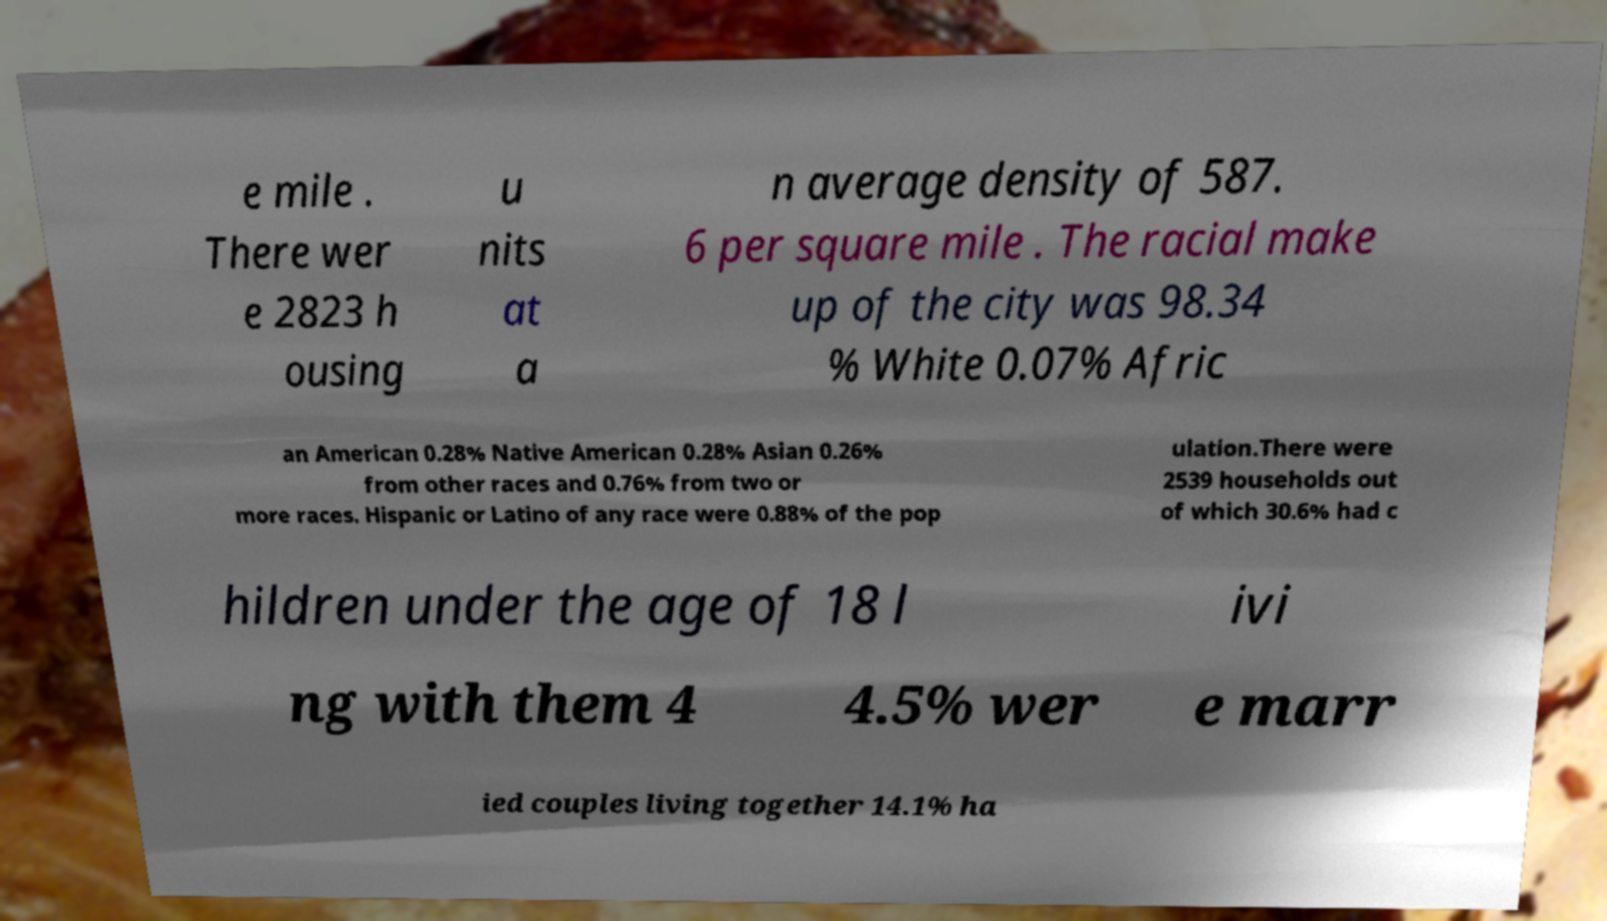Could you assist in decoding the text presented in this image and type it out clearly? e mile . There wer e 2823 h ousing u nits at a n average density of 587. 6 per square mile . The racial make up of the city was 98.34 % White 0.07% Afric an American 0.28% Native American 0.28% Asian 0.26% from other races and 0.76% from two or more races. Hispanic or Latino of any race were 0.88% of the pop ulation.There were 2539 households out of which 30.6% had c hildren under the age of 18 l ivi ng with them 4 4.5% wer e marr ied couples living together 14.1% ha 